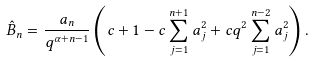Convert formula to latex. <formula><loc_0><loc_0><loc_500><loc_500>\hat { B } _ { n } = \frac { a _ { n } } { q ^ { \alpha + n - 1 } } \left ( c + 1 - c \sum _ { j = 1 } ^ { n + 1 } a _ { j } ^ { 2 } + c q ^ { 2 } \sum _ { j = 1 } ^ { n - 2 } a _ { j } ^ { 2 } \right ) .</formula> 